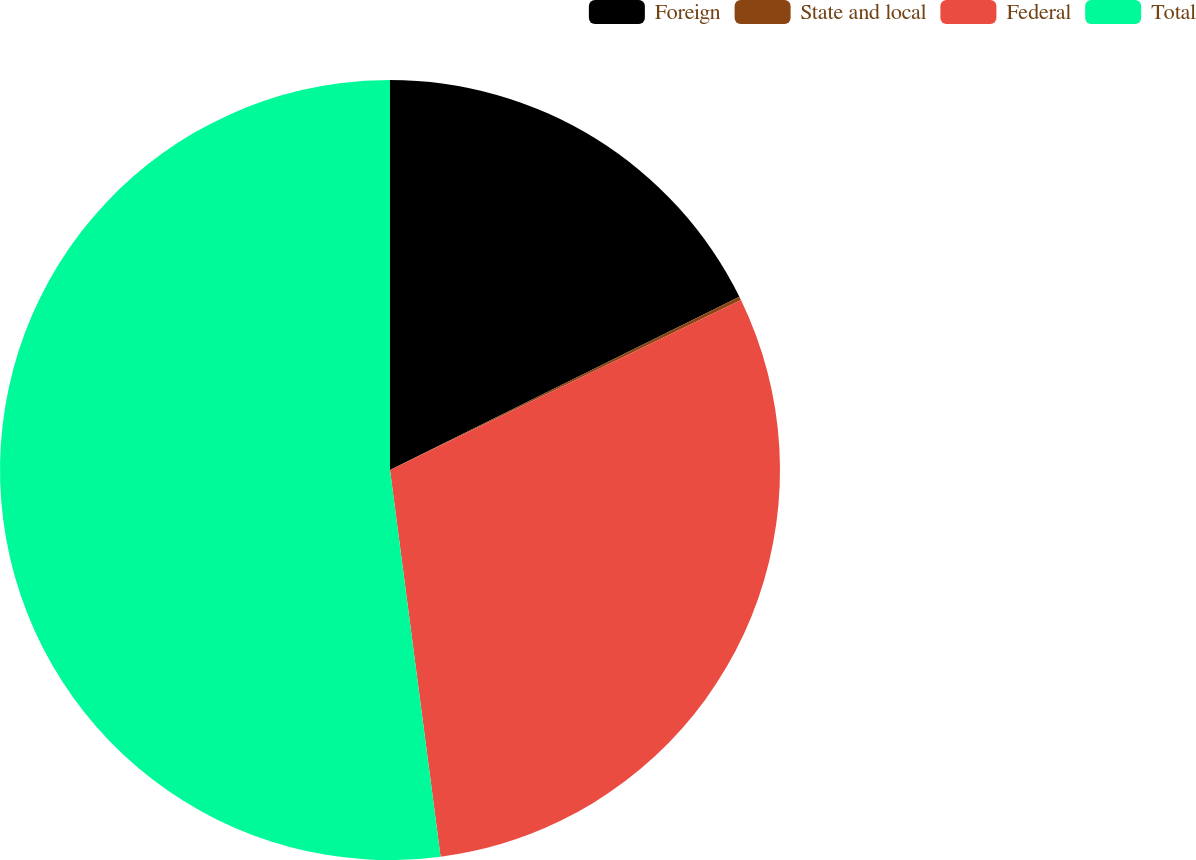Convert chart to OTSL. <chart><loc_0><loc_0><loc_500><loc_500><pie_chart><fcel>Foreign<fcel>State and local<fcel>Federal<fcel>Total<nl><fcel>17.67%<fcel>0.15%<fcel>30.11%<fcel>52.07%<nl></chart> 